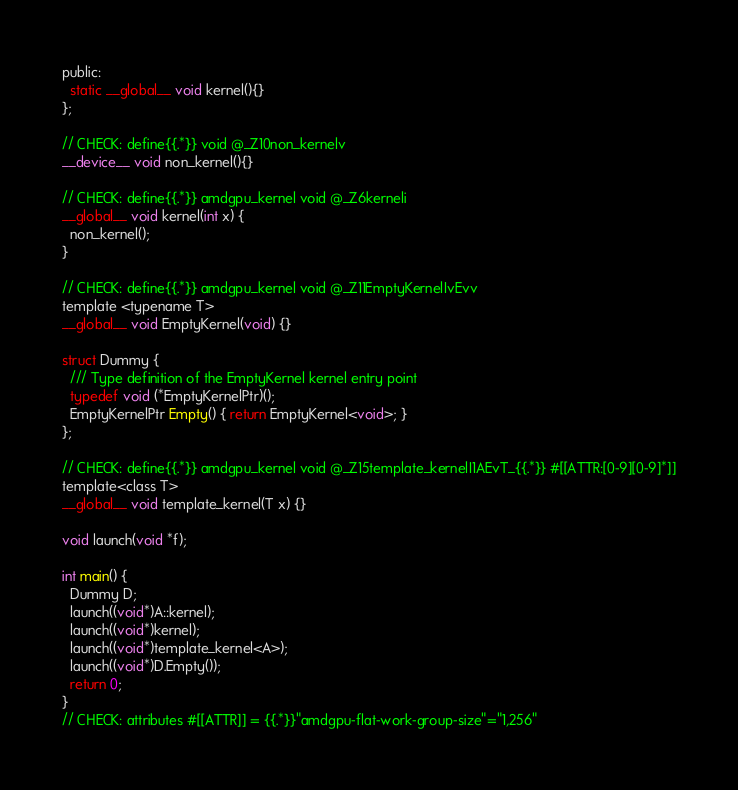Convert code to text. <code><loc_0><loc_0><loc_500><loc_500><_Cuda_>public:
  static __global__ void kernel(){}
};

// CHECK: define{{.*}} void @_Z10non_kernelv
__device__ void non_kernel(){}

// CHECK: define{{.*}} amdgpu_kernel void @_Z6kerneli
__global__ void kernel(int x) {
  non_kernel();
}

// CHECK: define{{.*}} amdgpu_kernel void @_Z11EmptyKernelIvEvv
template <typename T>
__global__ void EmptyKernel(void) {}

struct Dummy {
  /// Type definition of the EmptyKernel kernel entry point
  typedef void (*EmptyKernelPtr)();
  EmptyKernelPtr Empty() { return EmptyKernel<void>; } 
};

// CHECK: define{{.*}} amdgpu_kernel void @_Z15template_kernelI1AEvT_{{.*}} #[[ATTR:[0-9][0-9]*]]
template<class T>
__global__ void template_kernel(T x) {}

void launch(void *f);

int main() {
  Dummy D;
  launch((void*)A::kernel);
  launch((void*)kernel);
  launch((void*)template_kernel<A>);
  launch((void*)D.Empty());
  return 0;
}
// CHECK: attributes #[[ATTR]] = {{.*}}"amdgpu-flat-work-group-size"="1,256"
</code> 